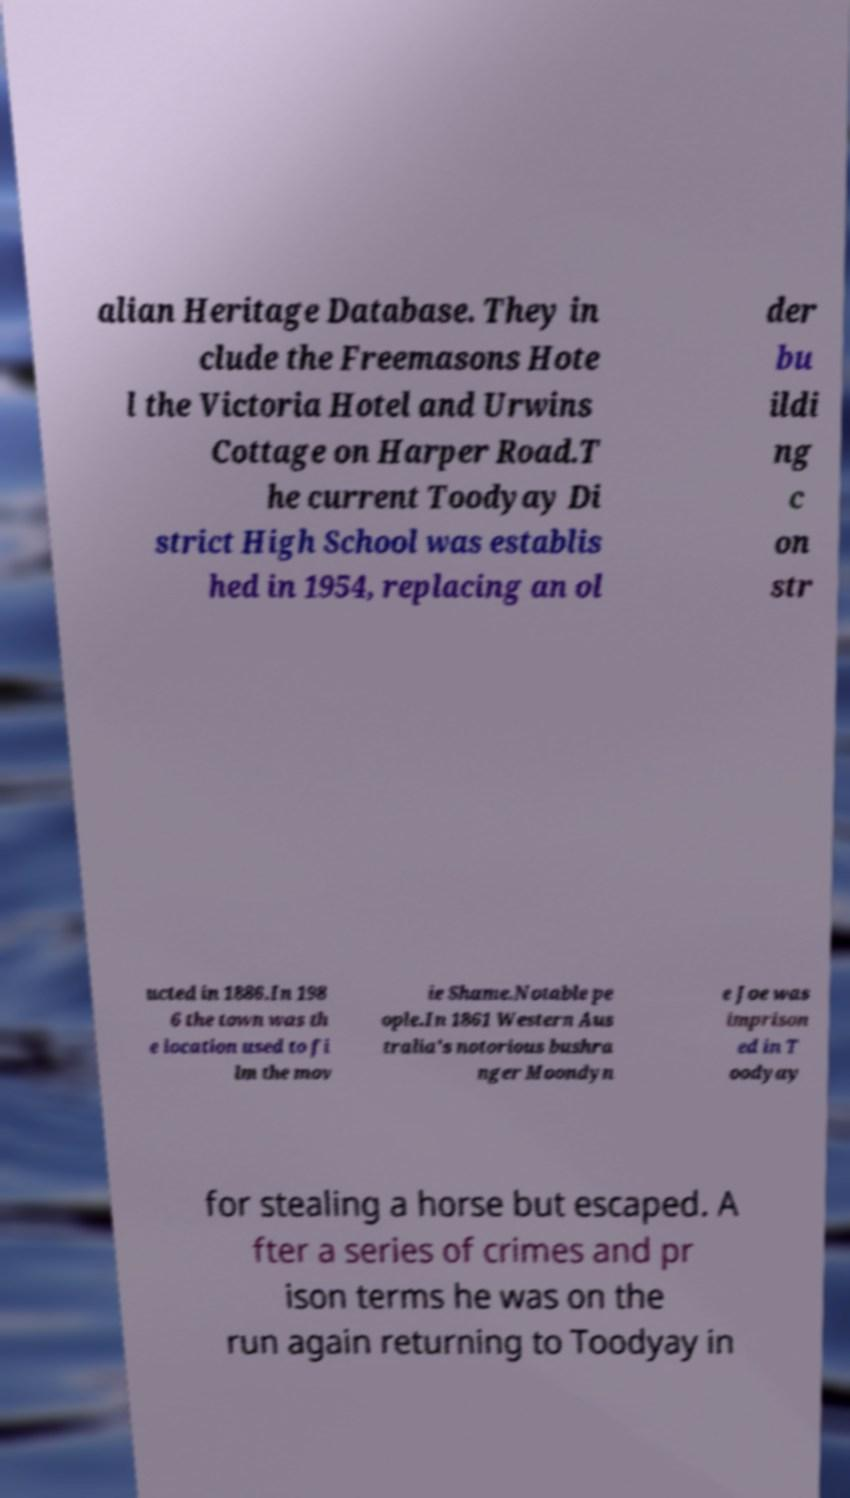I need the written content from this picture converted into text. Can you do that? alian Heritage Database. They in clude the Freemasons Hote l the Victoria Hotel and Urwins Cottage on Harper Road.T he current Toodyay Di strict High School was establis hed in 1954, replacing an ol der bu ildi ng c on str ucted in 1886.In 198 6 the town was th e location used to fi lm the mov ie Shame.Notable pe ople.In 1861 Western Aus tralia's notorious bushra nger Moondyn e Joe was imprison ed in T oodyay for stealing a horse but escaped. A fter a series of crimes and pr ison terms he was on the run again returning to Toodyay in 